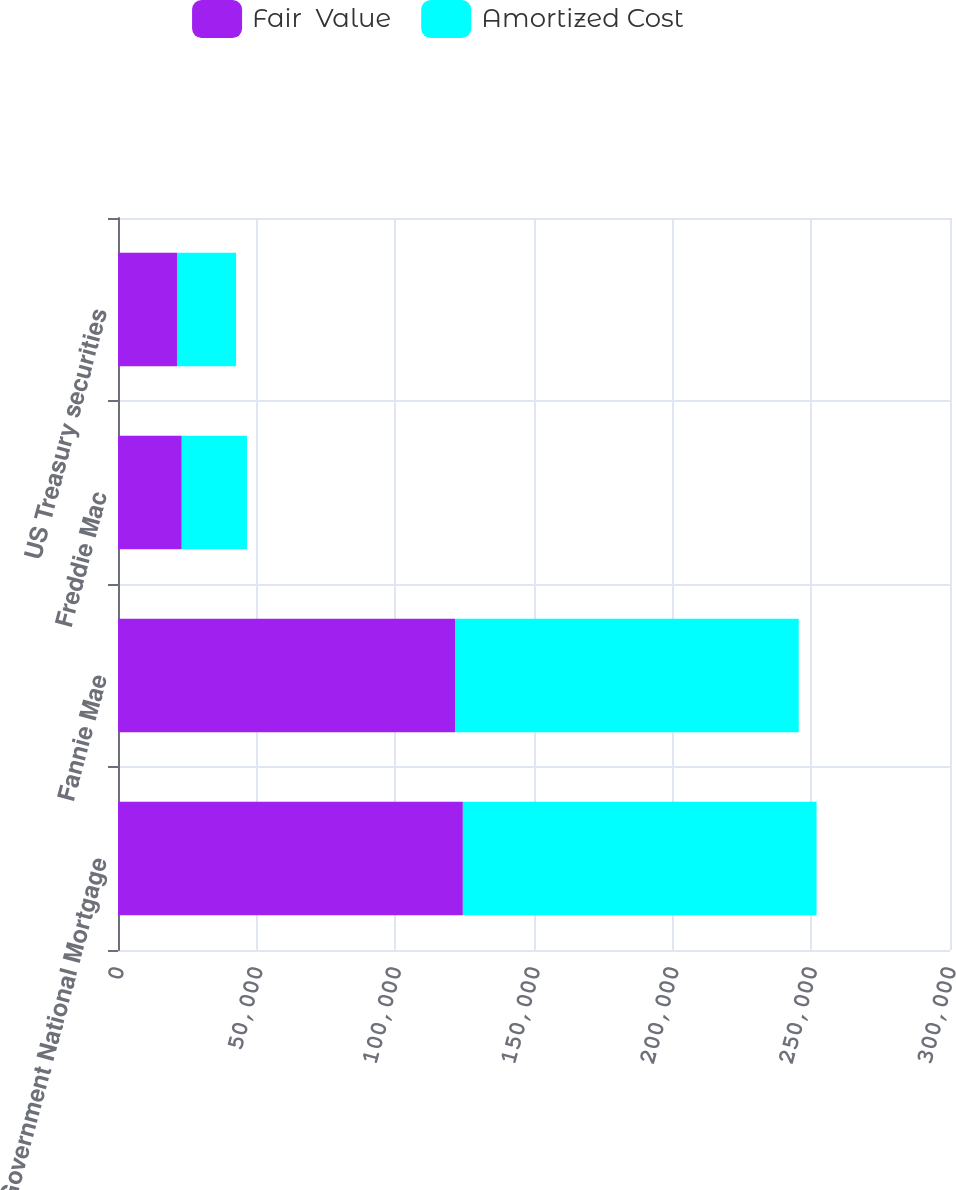<chart> <loc_0><loc_0><loc_500><loc_500><stacked_bar_chart><ecel><fcel>Government National Mortgage<fcel>Fannie Mae<fcel>Freddie Mac<fcel>US Treasury securities<nl><fcel>Fair  Value<fcel>124348<fcel>121522<fcel>22995<fcel>21269<nl><fcel>Amortized Cost<fcel>127541<fcel>123933<fcel>23502<fcel>21305<nl></chart> 